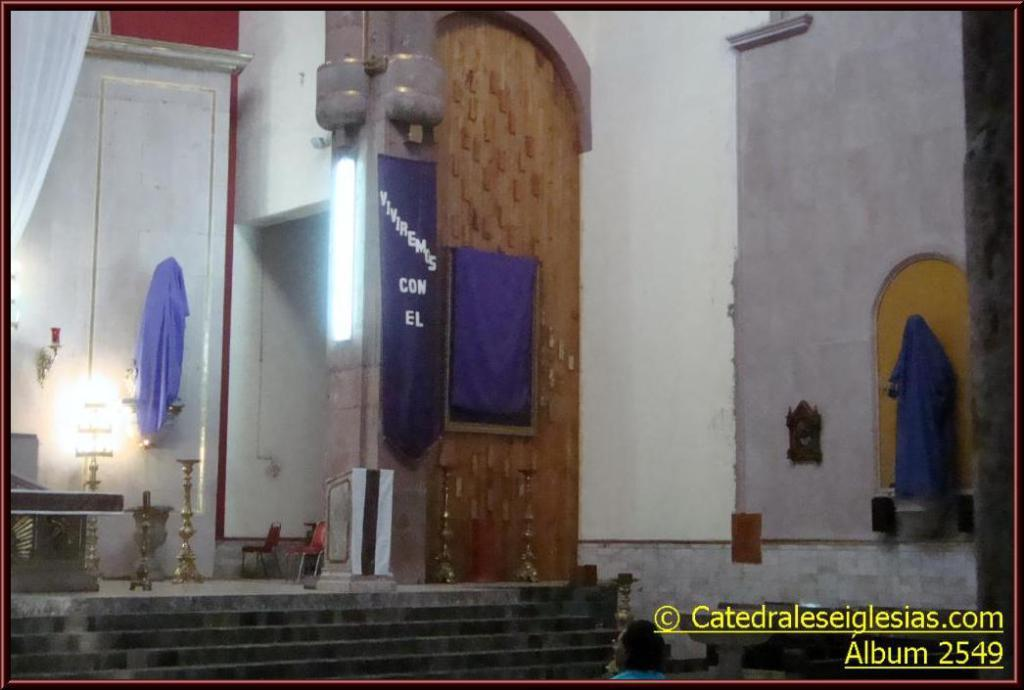What is present in the image that serves as a backdrop or barrier? There is a wall in the image. What is placed on the wall? There are items on the wall. What can be seen in the background of the image? There are towels and lights in the background of the image. Where is the text located in the image? There is some text in the bottom right corner of the image. What type of feast is being prepared in the image? There is no indication of a feast or any food preparation in the image. What time of day is depicted in the image? The time of day cannot be determined from the image alone, as there are no specific clues or indicators present. 